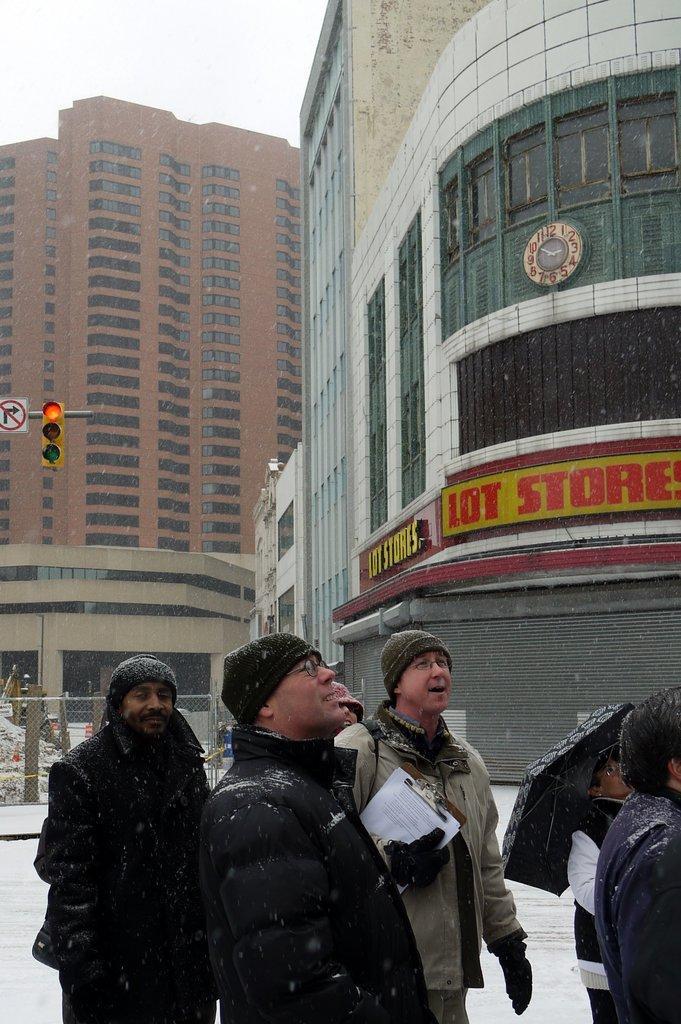Describe this image in one or two sentences. In this picture we can see a group of people standing on the ground, buildings with windows, fence, traffic signal light, signboard and in the background we can see the sky. 